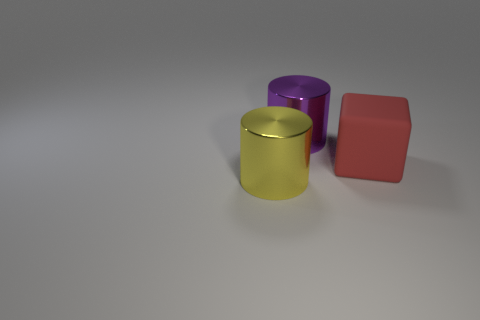Add 3 red objects. How many objects exist? 6 Subtract all cylinders. How many objects are left? 1 Subtract all purple cylinders. How many cylinders are left? 1 Subtract 1 cubes. How many cubes are left? 0 Subtract all purple cylinders. Subtract all brown cubes. How many cylinders are left? 1 Subtract all green balls. How many yellow cylinders are left? 1 Subtract all large yellow metallic things. Subtract all big matte blocks. How many objects are left? 1 Add 2 metal things. How many metal things are left? 4 Add 2 green shiny cylinders. How many green shiny cylinders exist? 2 Subtract 0 green blocks. How many objects are left? 3 